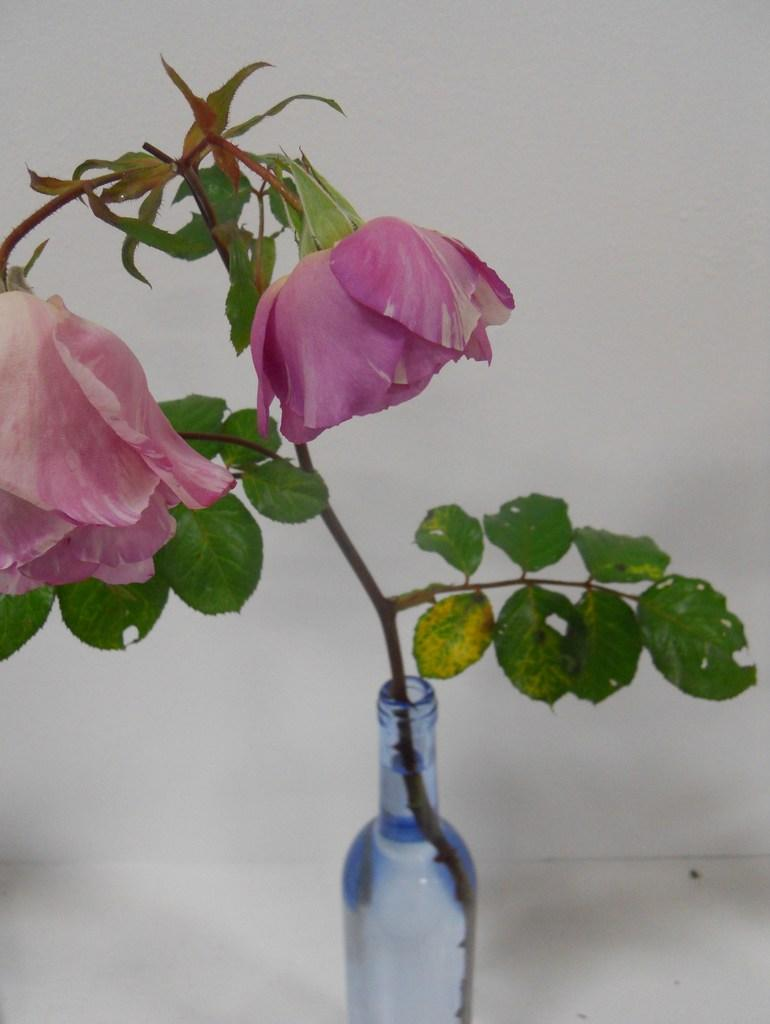What is inside the bottle that is visible in the image? There is a plant placed in the bottle. What color are the flowers on the plant? The plant has pink flowers. Where is the bottle with the plant located in the image? The bottle with the plant is placed on the floor. Are there any ants crawling on the plant in the image? There is no indication of ants or any other insects in the image. 